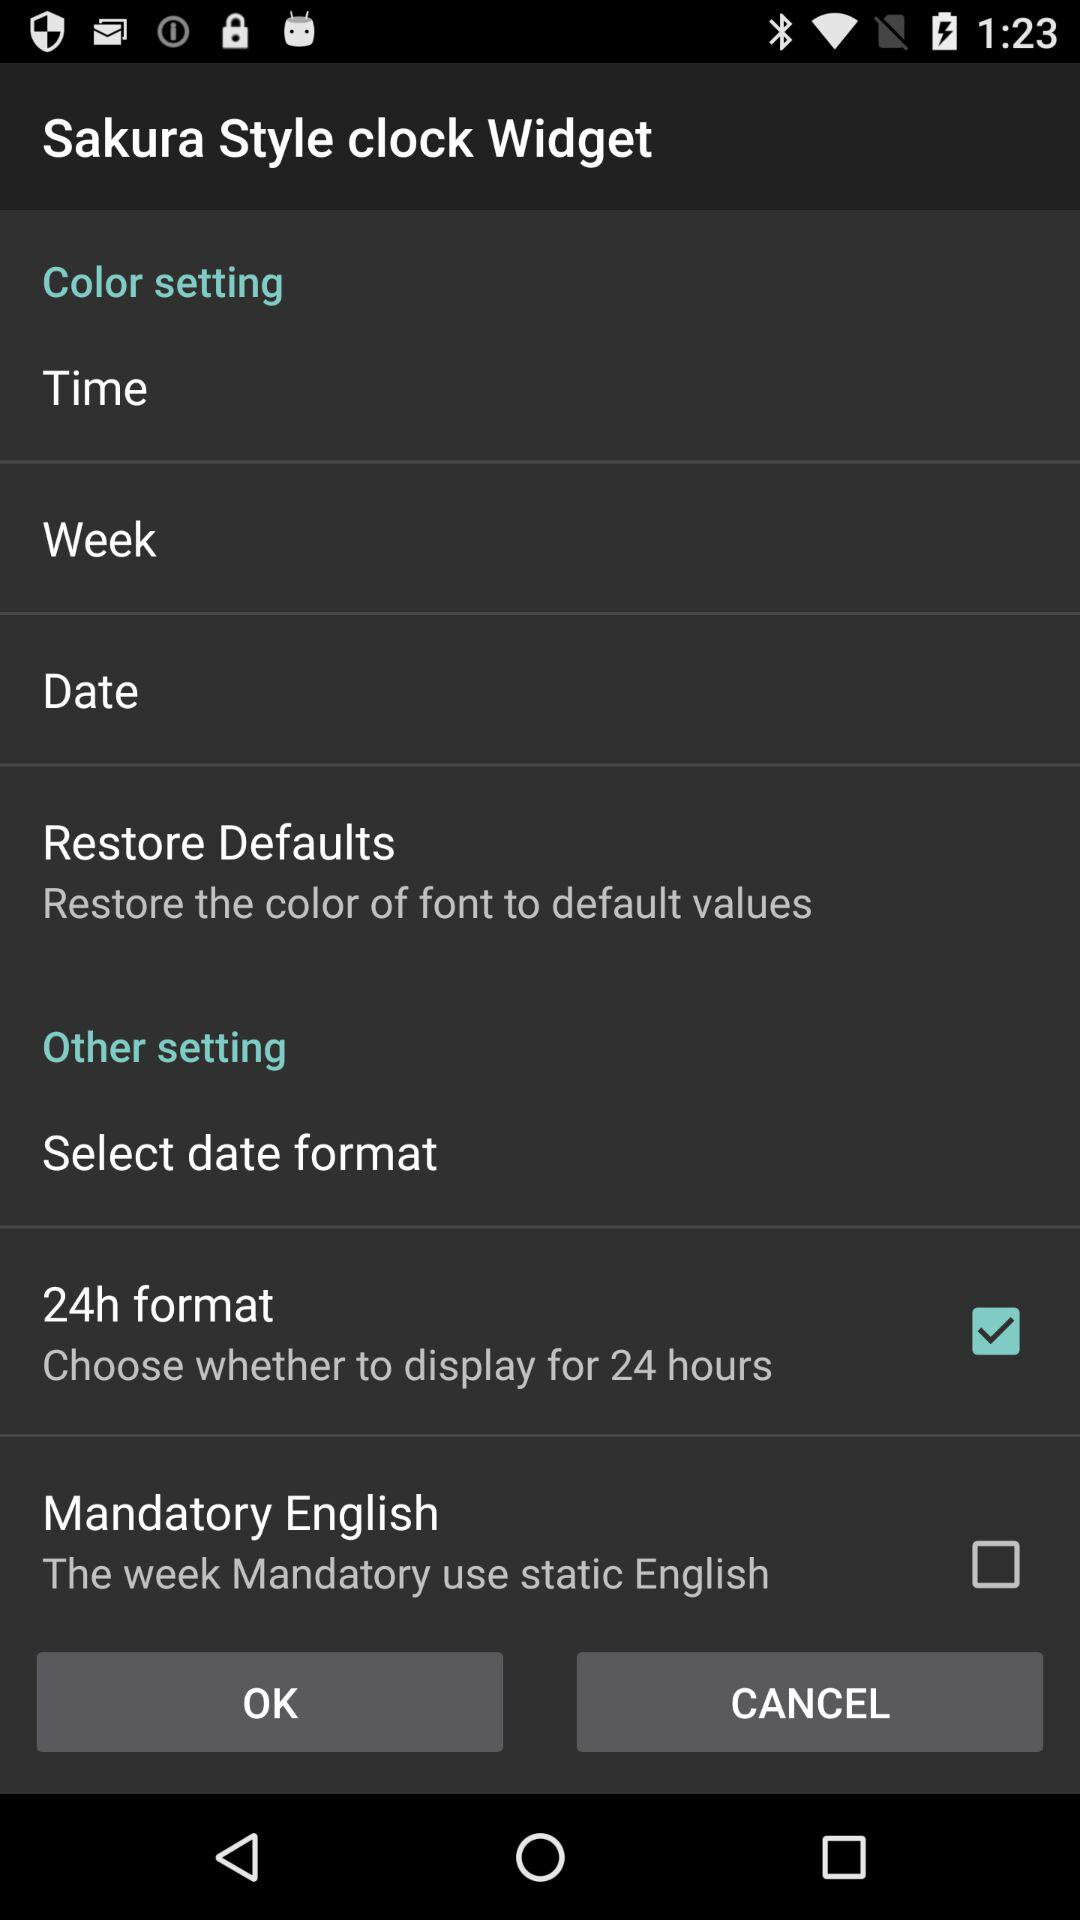What is the description of "Restore Defaults"? The description is "Restore the color of font to default values". 